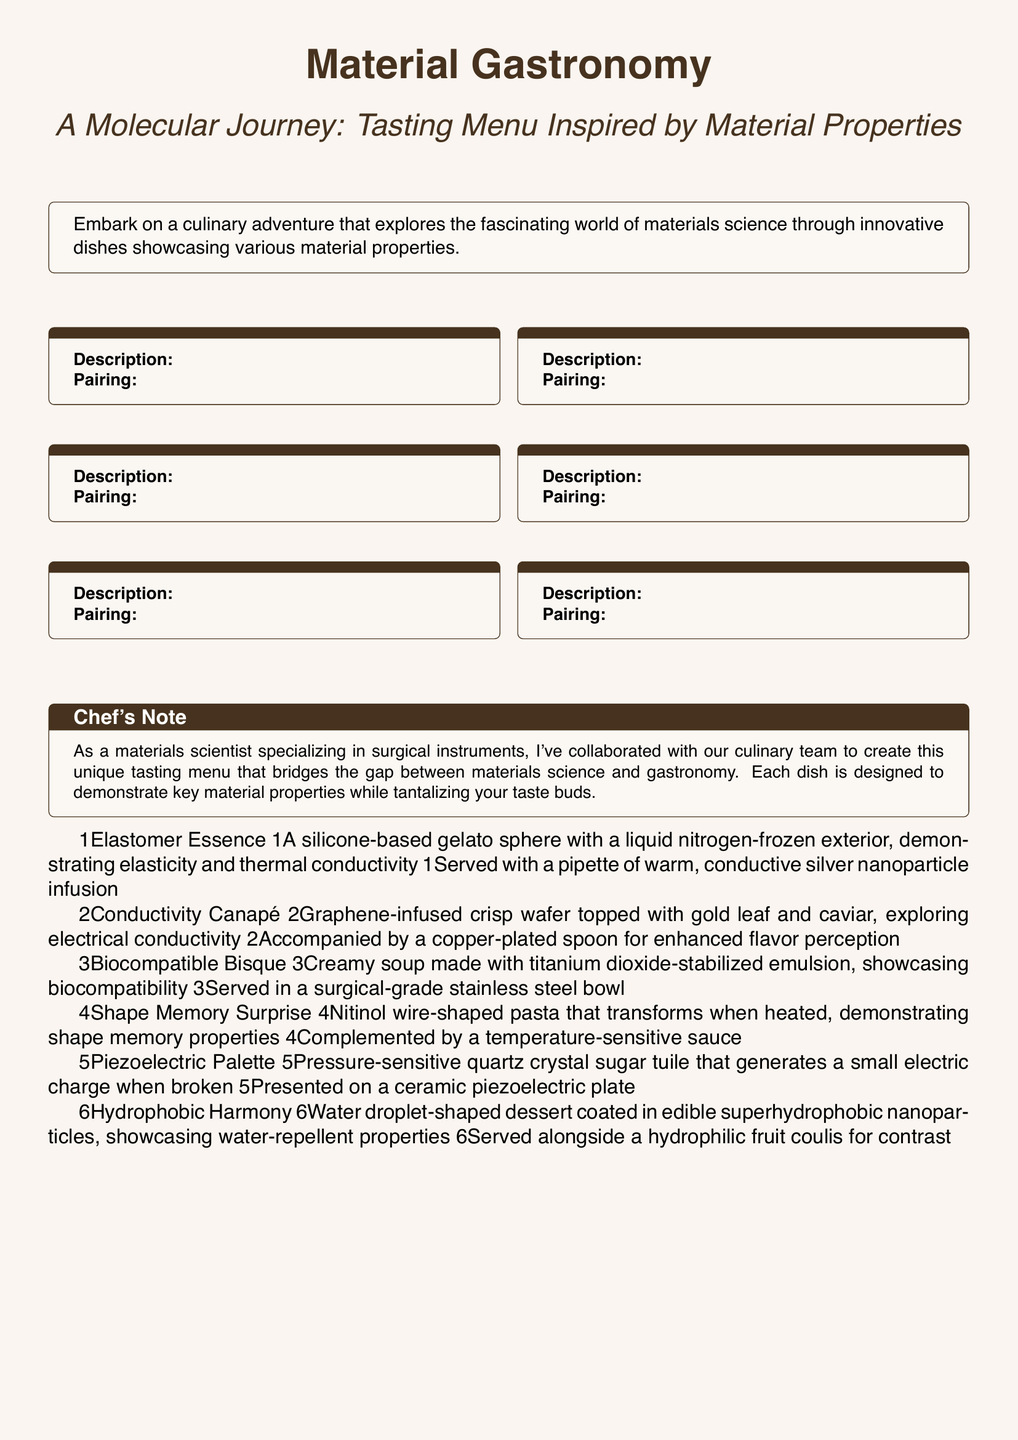What is the title of the menu? The title of the menu is prominently displayed at the top of the document.
Answer: Material Gastronomy What is the theme of the tasting menu? The theme is conveyed in the subtitle that describes the focus of the menu's dishes.
Answer: A Molecular Journey How many courses are featured in the menu? The menu lists a total of six courses under the culinary adventure description.
Answer: 6 What is the first dish in the tasting menu? The first dish is mentioned in the listing of courses at the beginning.
Answer: Elastomer Essence What property does the "Shape Memory Surprise" highlight? This dish focuses on a specific material property that is part of its description.
Answer: Shape memory properties What type of bowl is the "Biocompatible Bisque" served in? The serving vessel for the dish is stated in the pairing description.
Answer: Surgical-grade stainless steel bowl What unique feature does the "Piezoelectric Palette" have? The characteristic of the dish is detailed in its description.
Answer: Generates a small electric charge How is the "Hydrophobic Harmony" described in relation to material properties? The description highlights a specific functionality related to material science.
Answer: Water-repellent properties What element is infused in the "Conductivity Canapé"? The specific enhancement to the dish is identified in the description.
Answer: Graphene 